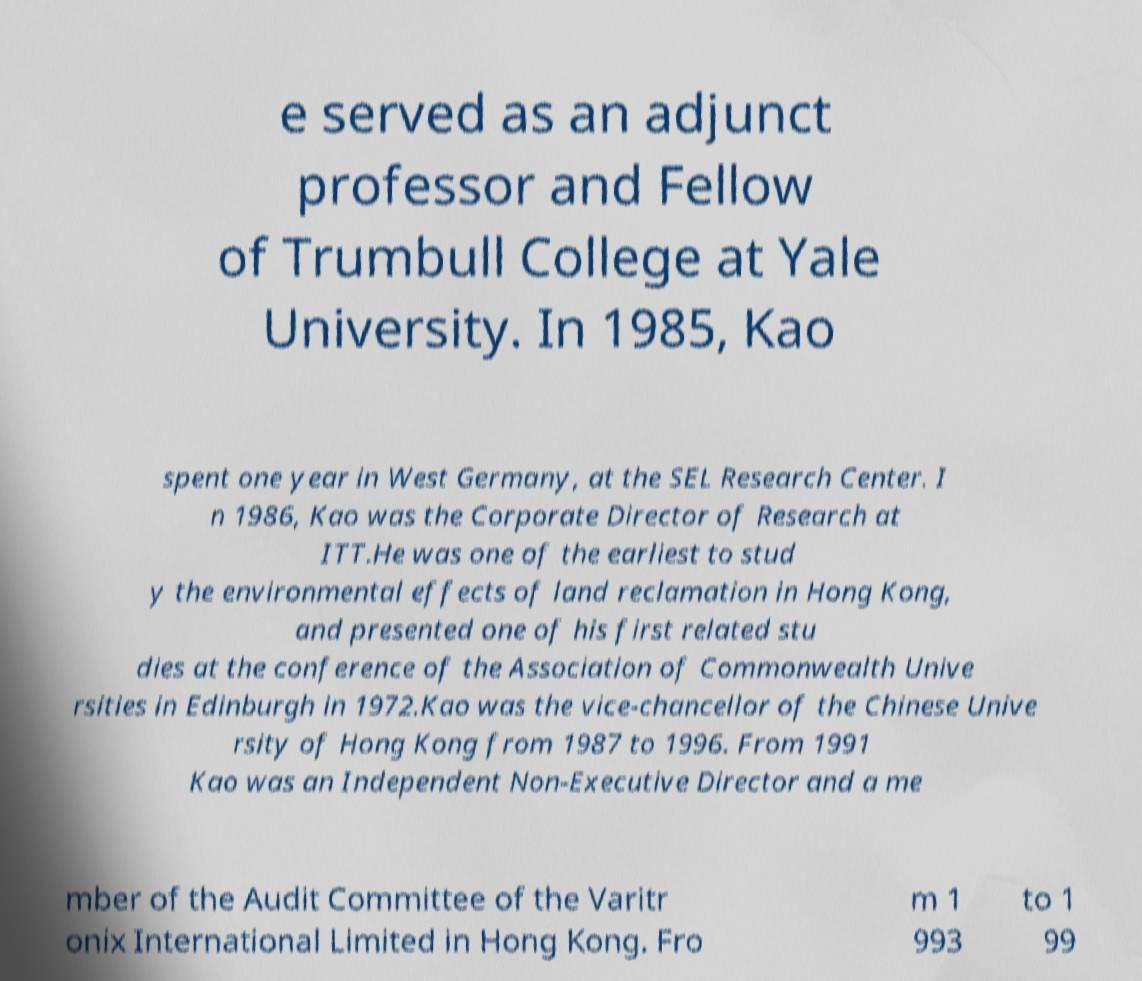There's text embedded in this image that I need extracted. Can you transcribe it verbatim? e served as an adjunct professor and Fellow of Trumbull College at Yale University. In 1985, Kao spent one year in West Germany, at the SEL Research Center. I n 1986, Kao was the Corporate Director of Research at ITT.He was one of the earliest to stud y the environmental effects of land reclamation in Hong Kong, and presented one of his first related stu dies at the conference of the Association of Commonwealth Unive rsities in Edinburgh in 1972.Kao was the vice-chancellor of the Chinese Unive rsity of Hong Kong from 1987 to 1996. From 1991 Kao was an Independent Non-Executive Director and a me mber of the Audit Committee of the Varitr onix International Limited in Hong Kong. Fro m 1 993 to 1 99 